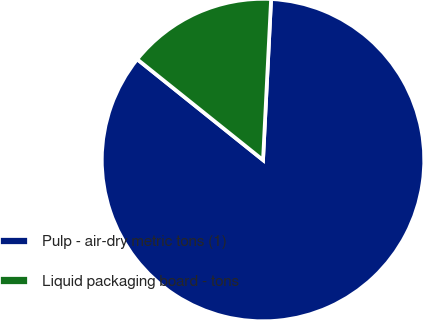Convert chart. <chart><loc_0><loc_0><loc_500><loc_500><pie_chart><fcel>Pulp - air-dry metric tons (1)<fcel>Liquid packaging board - tons<nl><fcel>84.95%<fcel>15.05%<nl></chart> 